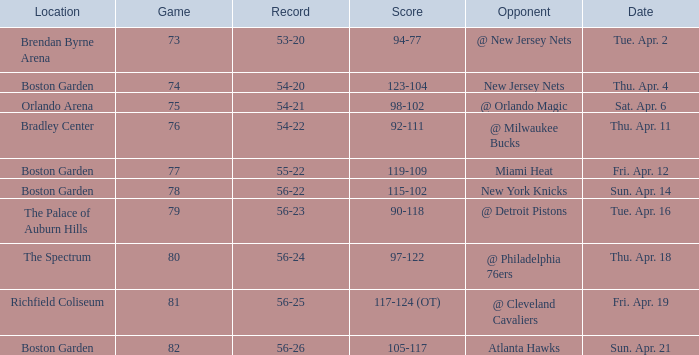When was the score 56-26? Sun. Apr. 21. 